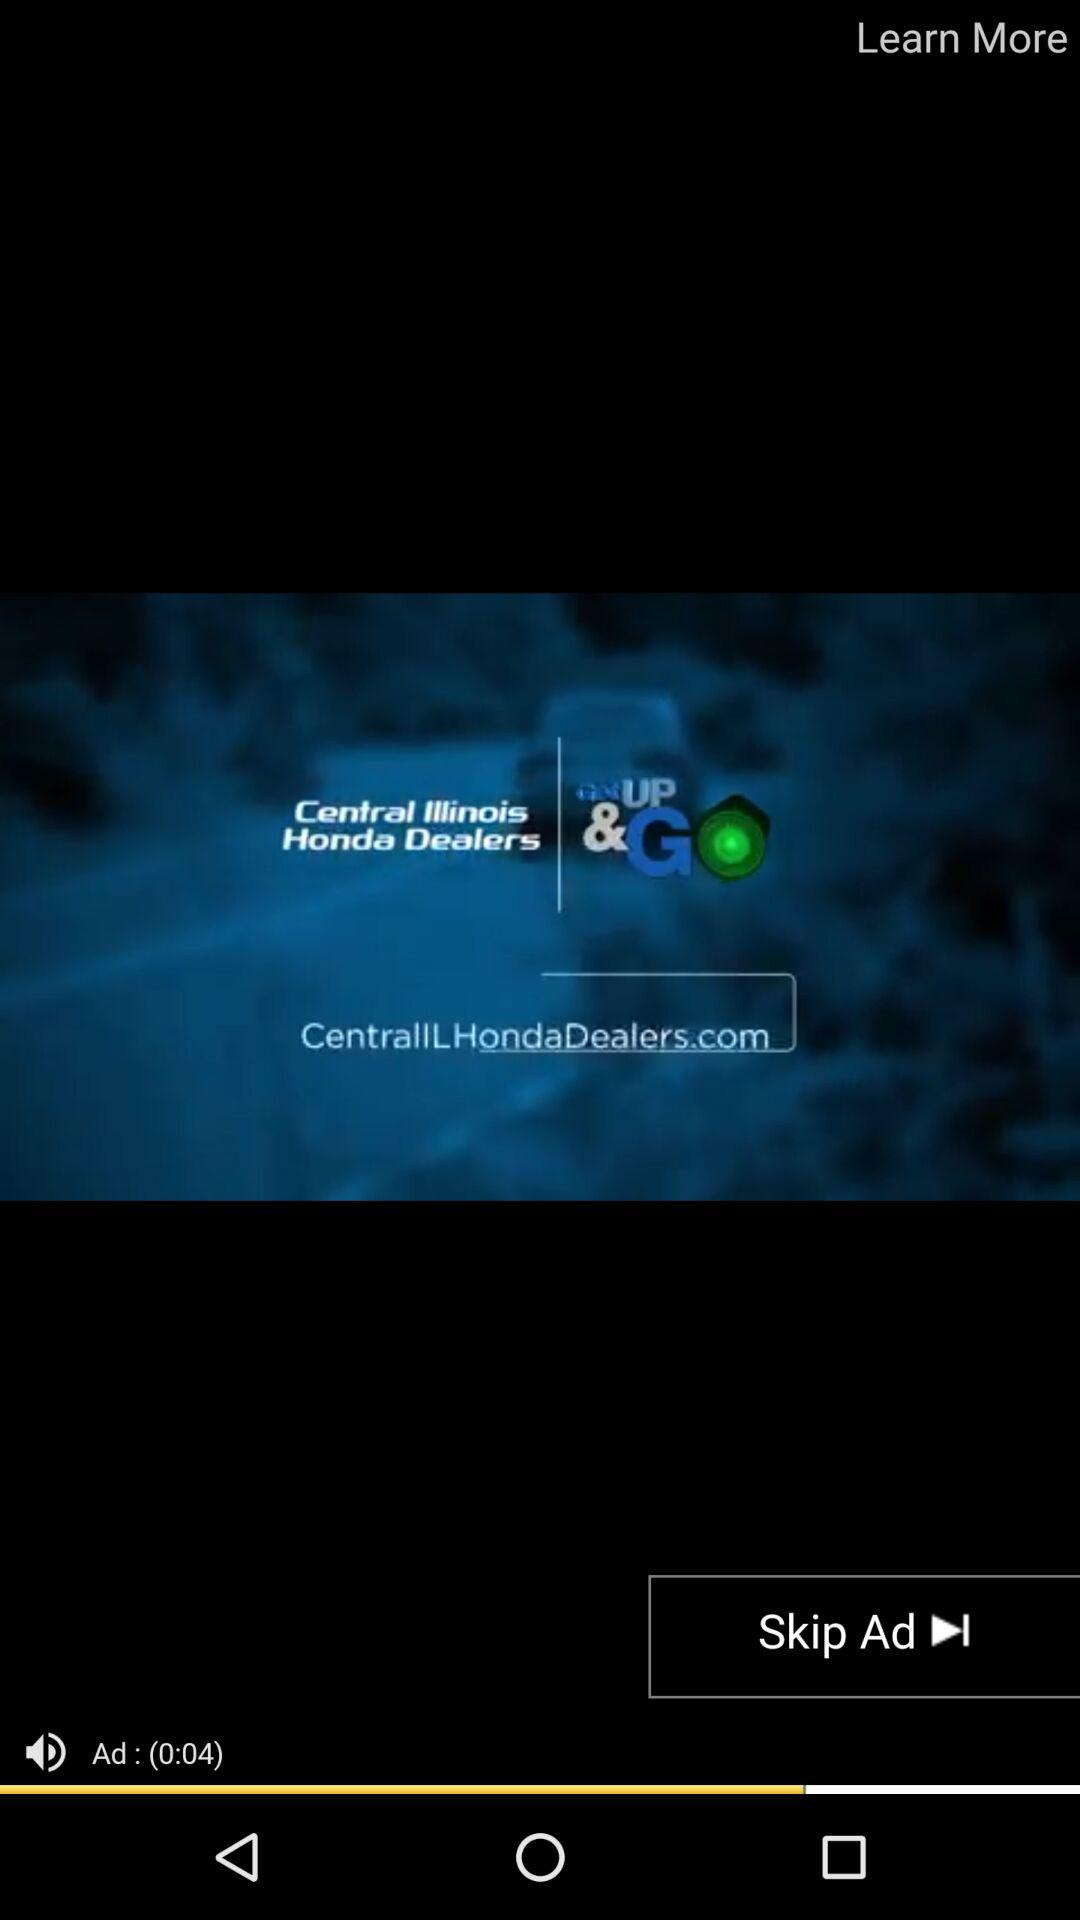How many seconds long is the ad?
Answer the question using a single word or phrase. 4 